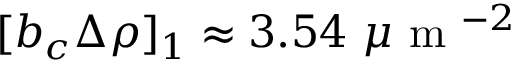<formula> <loc_0><loc_0><loc_500><loc_500>[ b _ { c } \Delta \rho ] _ { 1 } \approx 3 . 5 4 \mu m ^ { - 2 }</formula> 